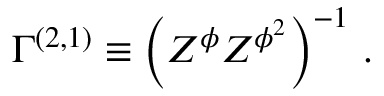<formula> <loc_0><loc_0><loc_500><loc_500>{ \Gamma } ^ { ( 2 , 1 ) } \equiv \left ( Z ^ { \phi } Z ^ { \phi ^ { 2 } } \right ) ^ { - 1 } \, .</formula> 